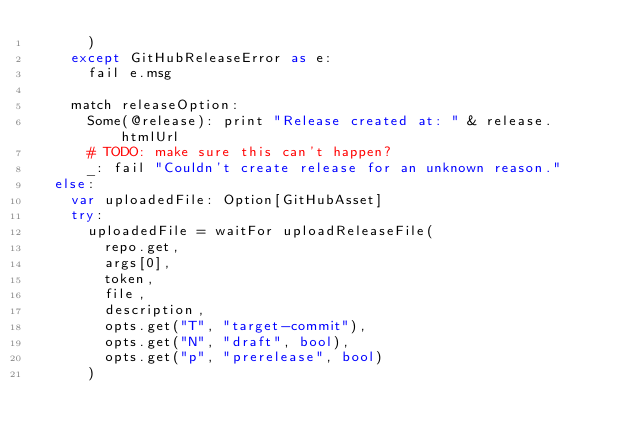Convert code to text. <code><loc_0><loc_0><loc_500><loc_500><_Nim_>      )
    except GitHubReleaseError as e:
      fail e.msg

    match releaseOption:
      Some(@release): print "Release created at: " & release.htmlUrl
      # TODO: make sure this can't happen?
      _: fail "Couldn't create release for an unknown reason."
  else:
    var uploadedFile: Option[GitHubAsset]
    try:
      uploadedFile = waitFor uploadReleaseFile(
        repo.get,
        args[0],
        token,
        file,
        description,
        opts.get("T", "target-commit"),
        opts.get("N", "draft", bool),
        opts.get("p", "prerelease", bool)
      )</code> 